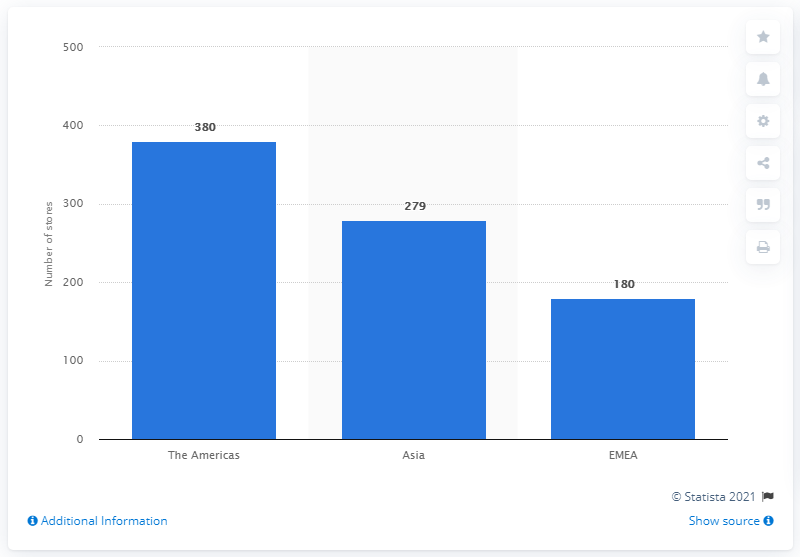Identify some key points in this picture. As of March 28, 2020, Michael Kors operated a total of 380 retail stores. 